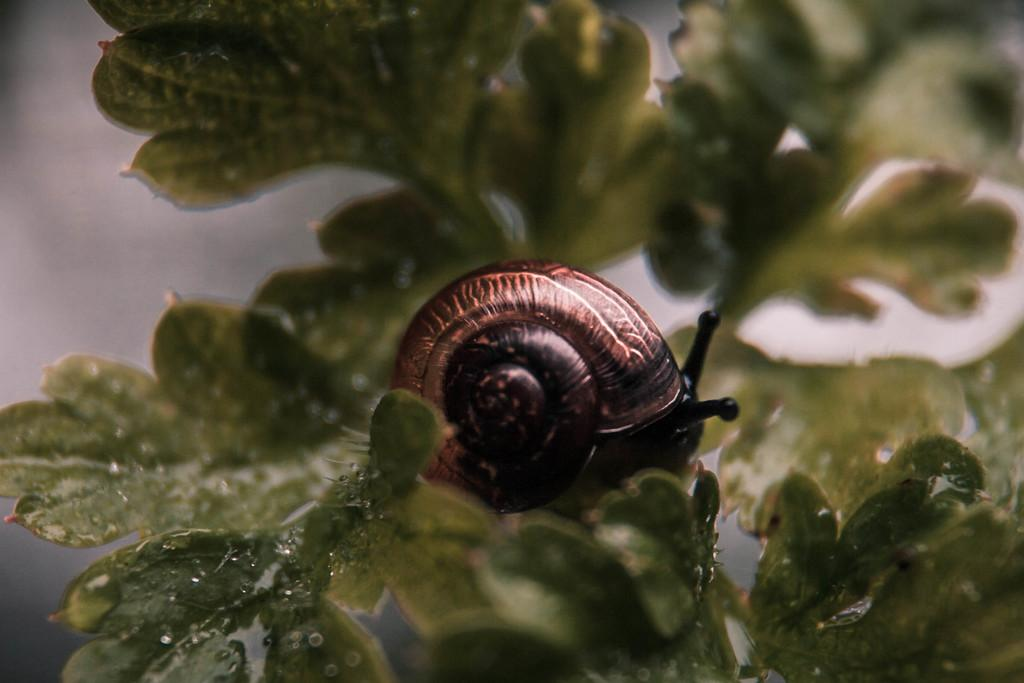What is the main subject of the image? There is a snail in the image. What is the color of the snail? The snail is brown in color. Where is the snail located? The snail is on a leaf. What is the color of the leaf? The leaf is green in color. What can be seen on the leaf besides the snail? There are water droplets on the leaf. How would you describe the background of the image? The background of the image is blurred. What type of plot is the snail using to climb the leaf in the image? The snail is not using a plot to climb the leaf; it moves using its muscular foot. How does the snail support itself while climbing the leaf in the image? The snail supports itself by secreting a slimy mucus that helps it adhere to surfaces, such as the leaf. 